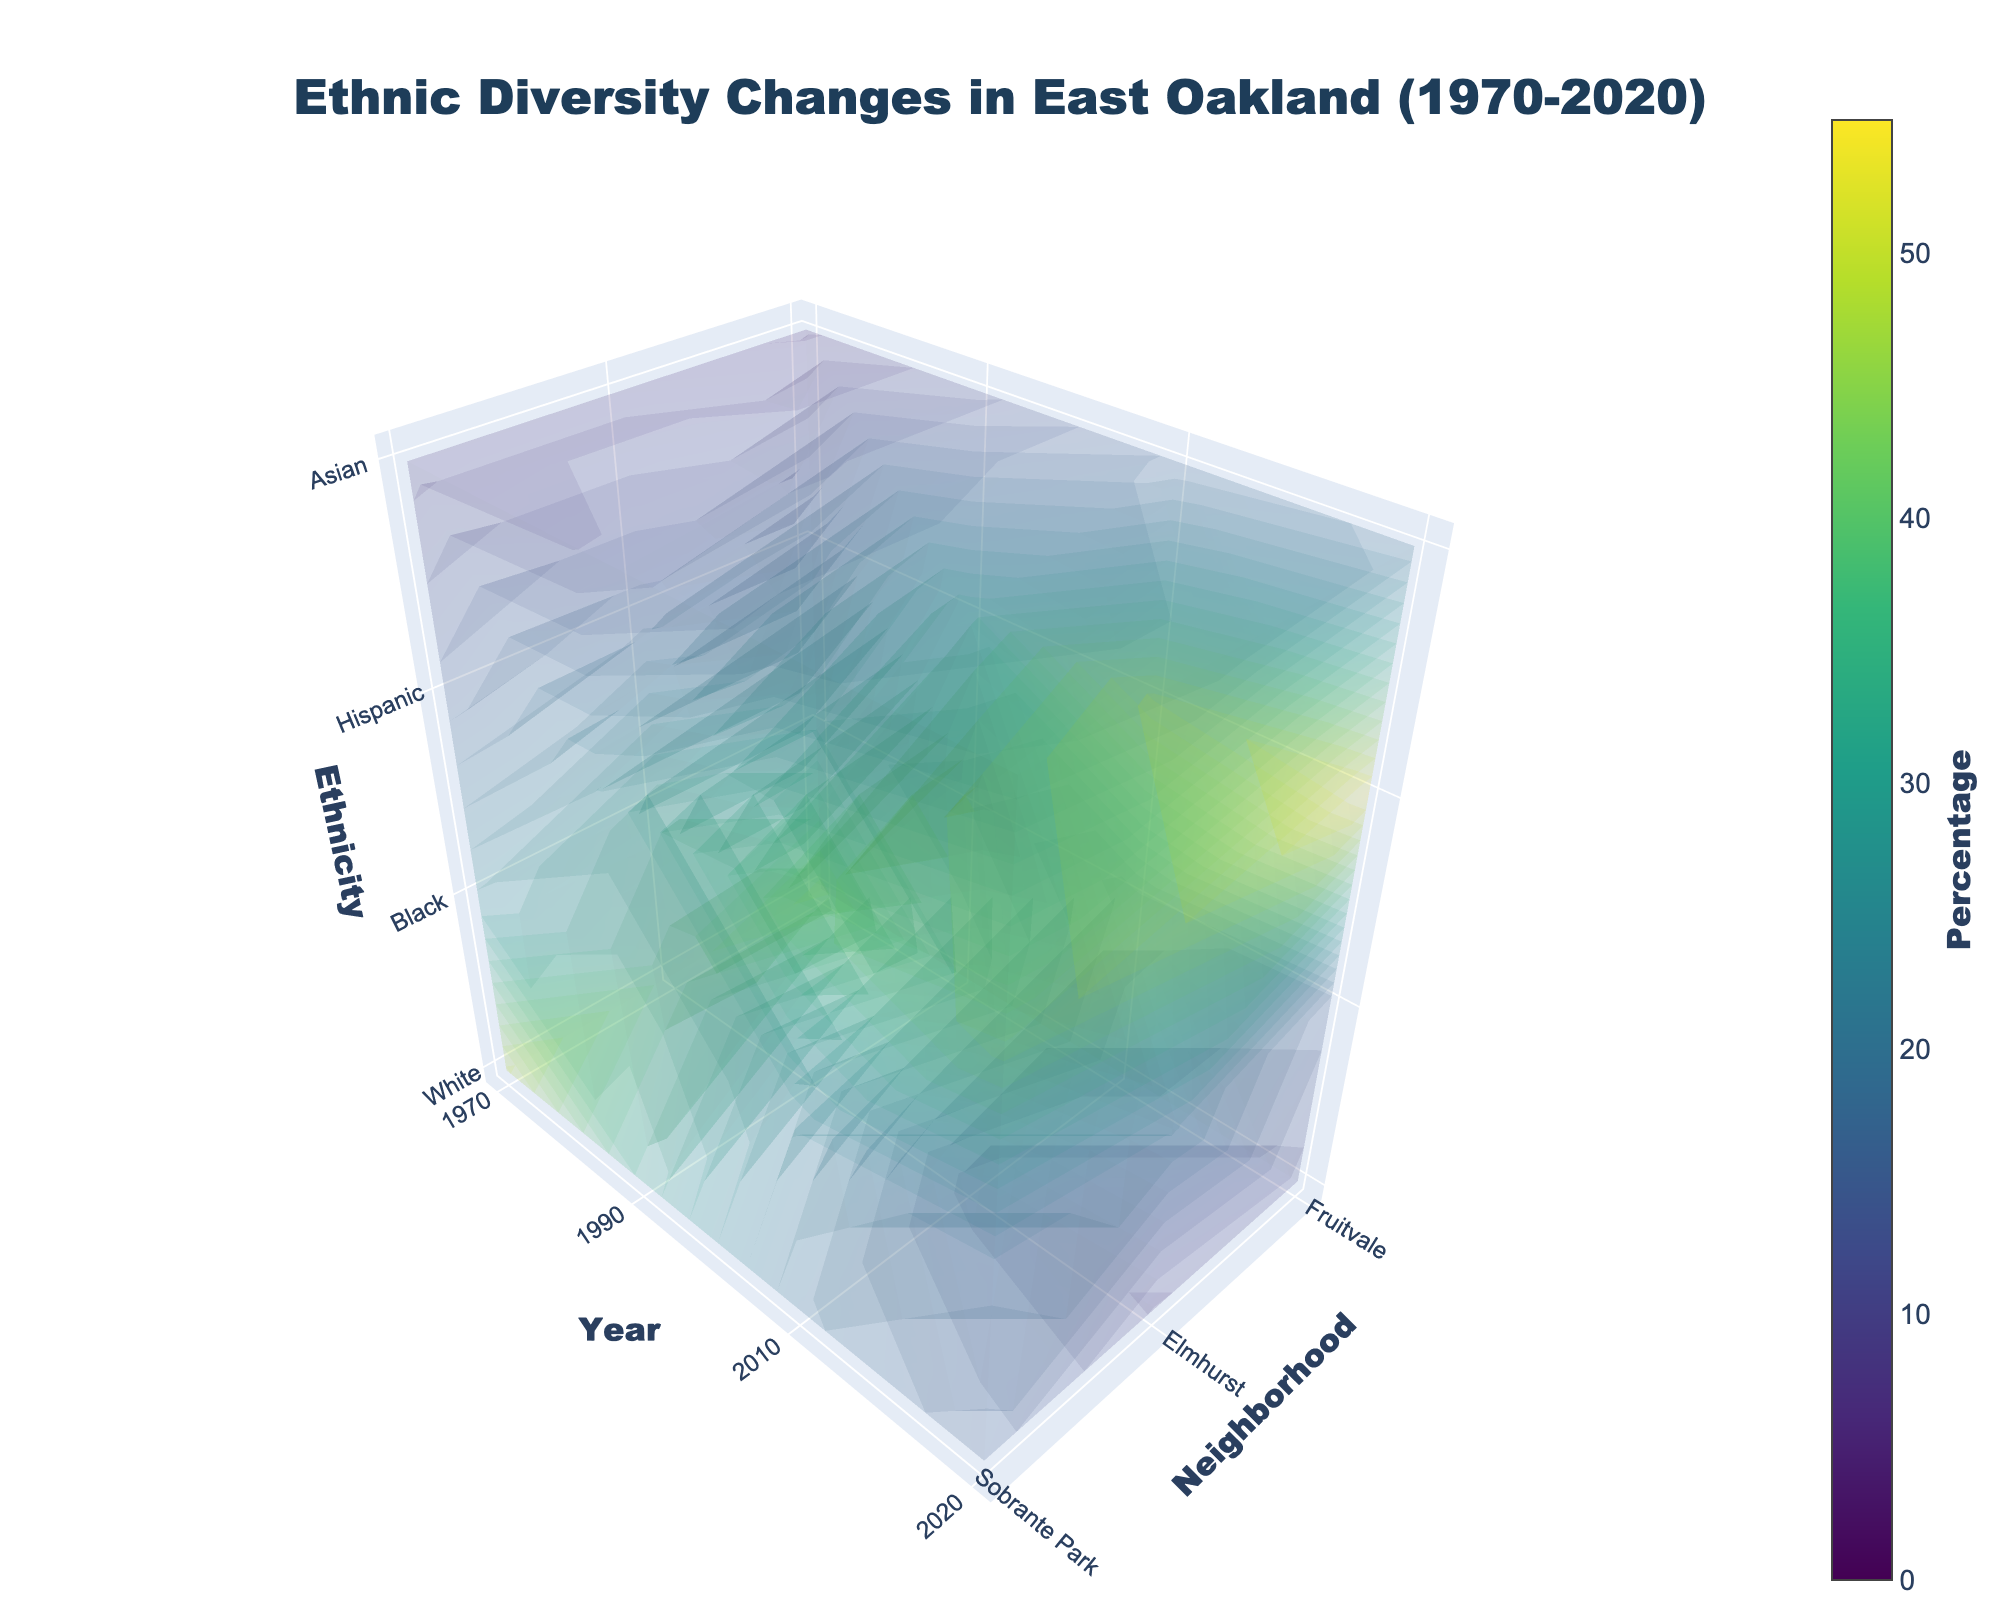What is the title of the figure? The title of the figure is displayed at the top center, indicating what the figure is about. It reads 'Ethnic Diversity Changes in East Oakland (1970-2020)'.
Answer: Ethnic Diversity Changes in East Oakland (1970-2020) Which ethnicity has the highest percentage in Fruitvale in 2020? By looking at the color scale for the year 2020 in the Fruitvale neighborhood, the highest value is assigned to the Hispanic ethnicity.
Answer: Hispanic How many neighborhoods are represented in the figure? The number of neighborhoods is indicated on the x-axis. By counting the tick marks, we see there are three neighborhoods: Fruitvale, Elmhurst, and Sobrante Park.
Answer: 3 Which neighborhood showed the biggest decrease in the white population from 1970 to 2020? Checking the figures from 1970 and 2020, the largest decrease in the white population is observed in Fruitvale (from 45% to 10%).
Answer: Fruitvale What is the overall trend in the Asian population across all neighborhoods from 1970 to 2020? By following the colors representing the Asian population from 1970 to 2020 along the 'Year' axis, we see a continual increase in the percentage of Asians in all neighborhoods.
Answer: Increasing Which year had the highest percentage of Black population in Elmhurst? By looking at the color indicators and values of the Black population in Elmhurst over the years, 1990 has the highest percentage (40%).
Answer: 1990 Across all neighborhoods, which ethnic group shows a general increase in their proportions from 1970 to 2020? Observing the colors for each ethnicity over the years reveals that Hispanic populations generally show an increasing trend across all neighborhoods.
Answer: Hispanic Which neighborhood had the highest percentage of Hispanic population in the earliest year available? In 1970, among the three neighborhoods, Sobrante Park had the lowest percentage of Hispanics, with Fruitvale having the highest percentage (20%).
Answer: Fruitvale What major trend can be observed in the Black population in Sobrante Park between 1970 and 2020? By looking at the color and percentage values for the Black population in Sobrante Park over the years, a decreasing trend can be noted (from 28% in 1970 to 20% in 2020).
Answer: Decreasing In which neighborhood did the Asian population remain relatively stable from 1970 to 2010? The Asian population percentage in Elmhurst saw only small changes from 1970 (7%) to 2010 (15%), signifying relative stability.
Answer: Elmhurst 